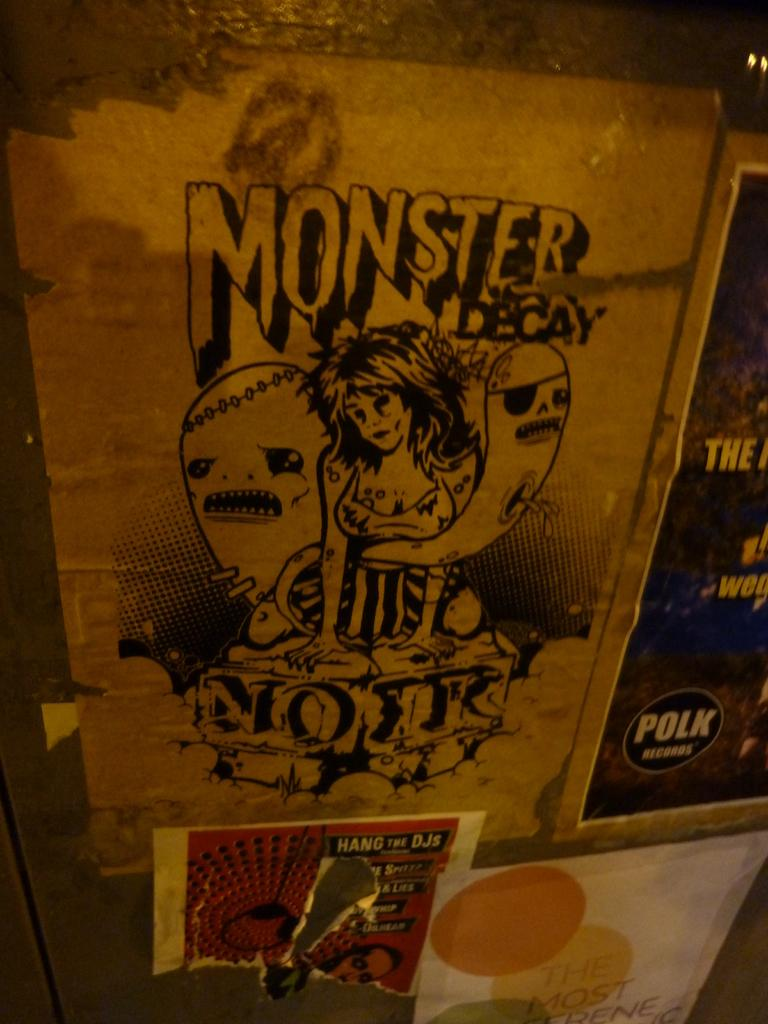What can be seen on the wall in the image? There are posters on the wall in the image. What is depicted in the posters? The posters contain a sketch of people. Are there any words or letters on the posters? Yes, there is text on the posters. Can you see a goat chewing on a quill in the image? No, there is no goat or quill present in the image. 